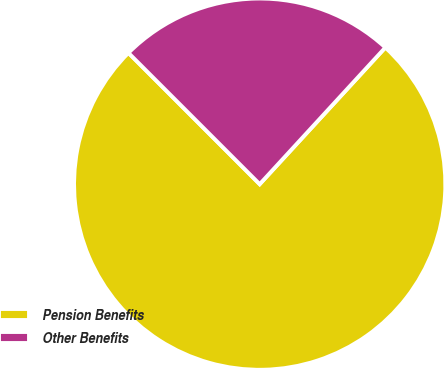<chart> <loc_0><loc_0><loc_500><loc_500><pie_chart><fcel>Pension Benefits<fcel>Other Benefits<nl><fcel>75.67%<fcel>24.33%<nl></chart> 